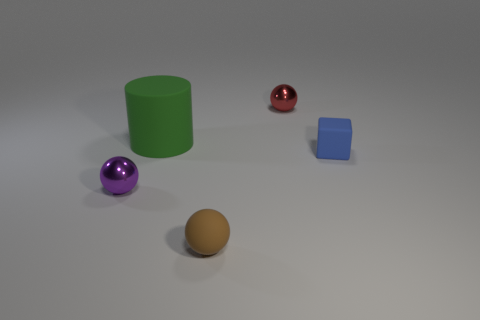Add 2 tiny cyan metal cylinders. How many objects exist? 7 Subtract all blocks. How many objects are left? 4 Subtract 0 yellow cylinders. How many objects are left? 5 Subtract all big green cylinders. Subtract all blocks. How many objects are left? 3 Add 3 green matte cylinders. How many green matte cylinders are left? 4 Add 4 big purple blocks. How many big purple blocks exist? 4 